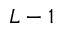Convert formula to latex. <formula><loc_0><loc_0><loc_500><loc_500>L - 1</formula> 